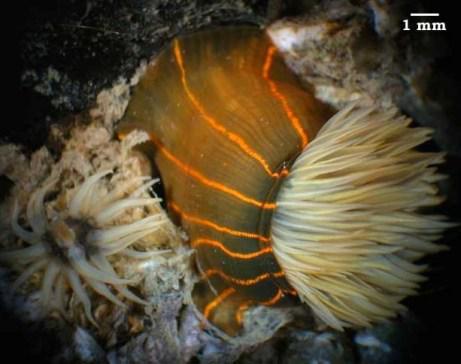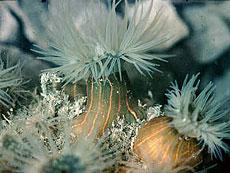The first image is the image on the left, the second image is the image on the right. Assess this claim about the two images: "The left image shows a side view of an anemone with an orange stalk and orange tendrils, and the right image shows a rounded orange anemone with no stalk.". Correct or not? Answer yes or no. No. 